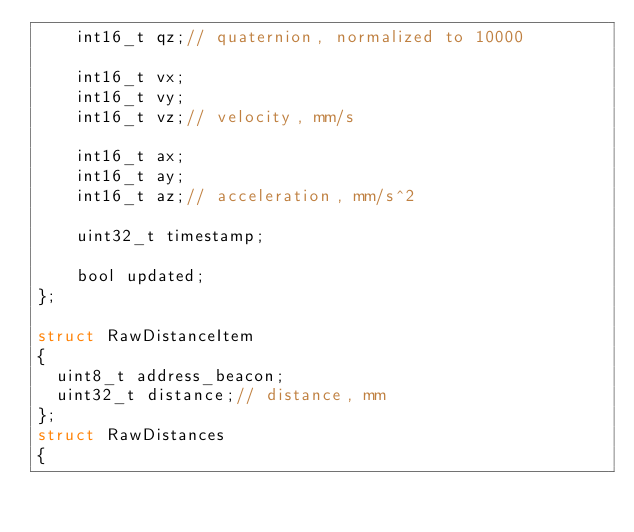<code> <loc_0><loc_0><loc_500><loc_500><_C_>    int16_t qz;// quaternion, normalized to 10000

    int16_t vx;
    int16_t vy;
    int16_t vz;// velocity, mm/s

    int16_t ax;
    int16_t ay;
    int16_t az;// acceleration, mm/s^2

    uint32_t timestamp;

    bool updated;
};

struct RawDistanceItem
{
  uint8_t address_beacon;
  uint32_t distance;// distance, mm
};
struct RawDistances
{</code> 